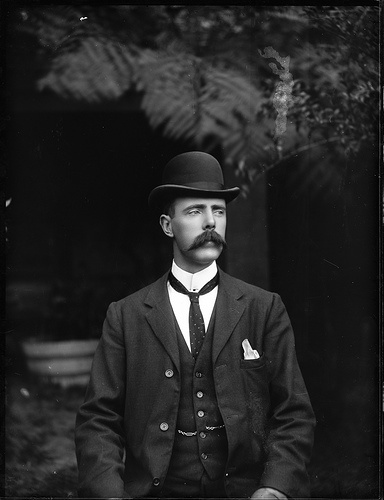Describe the objects in this image and their specific colors. I can see people in black, gray, white, and darkgray tones and tie in black, gray, darkgray, and white tones in this image. 